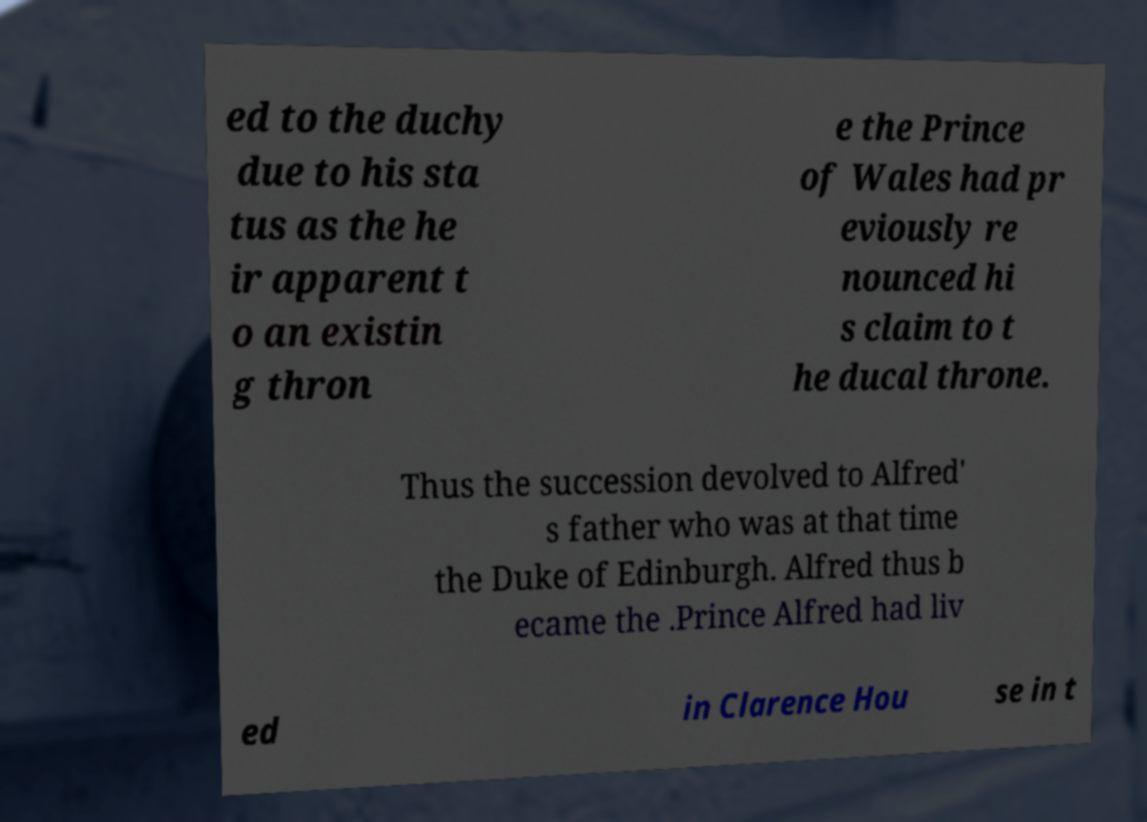There's text embedded in this image that I need extracted. Can you transcribe it verbatim? ed to the duchy due to his sta tus as the he ir apparent t o an existin g thron e the Prince of Wales had pr eviously re nounced hi s claim to t he ducal throne. Thus the succession devolved to Alfred' s father who was at that time the Duke of Edinburgh. Alfred thus b ecame the .Prince Alfred had liv ed in Clarence Hou se in t 